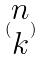<formula> <loc_0><loc_0><loc_500><loc_500>( \begin{matrix} n \\ k \end{matrix} )</formula> 